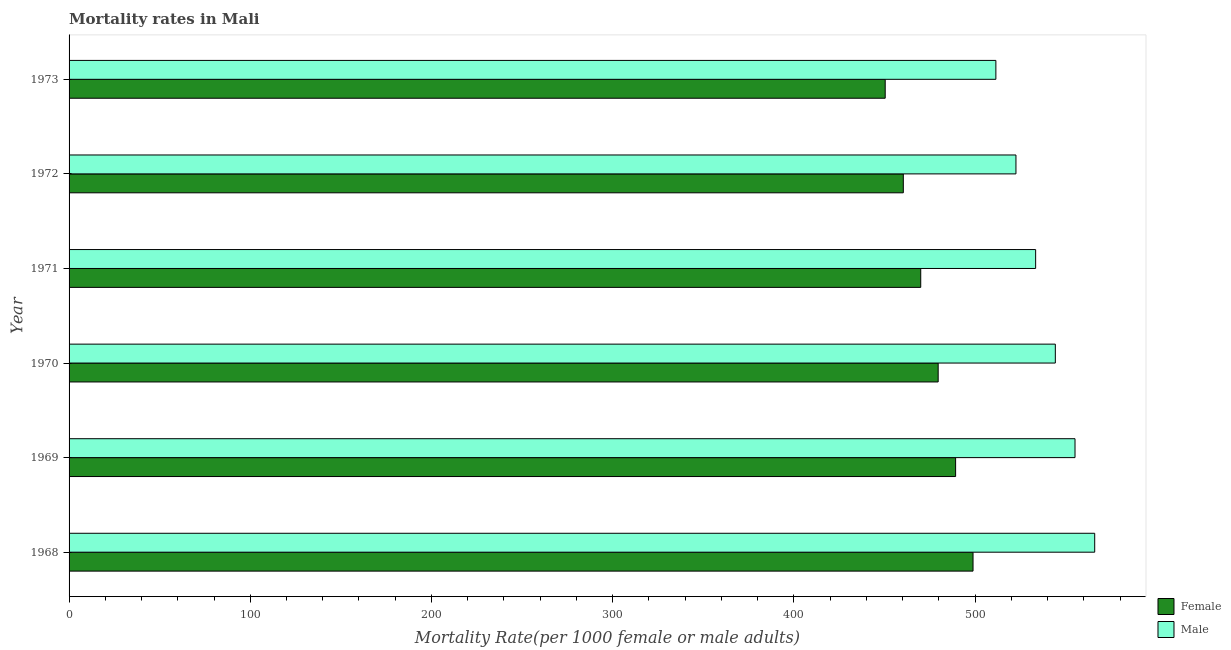How many bars are there on the 5th tick from the top?
Offer a terse response. 2. In how many cases, is the number of bars for a given year not equal to the number of legend labels?
Your response must be concise. 0. What is the male mortality rate in 1972?
Offer a very short reply. 522.56. Across all years, what is the maximum male mortality rate?
Your answer should be very brief. 566.02. Across all years, what is the minimum male mortality rate?
Offer a terse response. 511.48. In which year was the male mortality rate maximum?
Keep it short and to the point. 1968. In which year was the female mortality rate minimum?
Your answer should be very brief. 1973. What is the total female mortality rate in the graph?
Provide a short and direct response. 2848.58. What is the difference between the female mortality rate in 1969 and that in 1973?
Give a very brief answer. 38.85. What is the difference between the female mortality rate in 1968 and the male mortality rate in 1969?
Your response must be concise. -56.28. What is the average male mortality rate per year?
Your response must be concise. 538.82. In the year 1973, what is the difference between the female mortality rate and male mortality rate?
Provide a succinct answer. -61.07. What is the ratio of the female mortality rate in 1969 to that in 1973?
Provide a succinct answer. 1.09. Is the female mortality rate in 1968 less than that in 1973?
Make the answer very short. No. Is the difference between the male mortality rate in 1970 and 1973 greater than the difference between the female mortality rate in 1970 and 1973?
Your answer should be compact. Yes. What is the difference between the highest and the second highest female mortality rate?
Give a very brief answer. 9.62. What is the difference between the highest and the lowest male mortality rate?
Give a very brief answer. 54.54. In how many years, is the male mortality rate greater than the average male mortality rate taken over all years?
Ensure brevity in your answer.  3. What does the 2nd bar from the top in 1971 represents?
Your answer should be compact. Female. How many bars are there?
Your answer should be very brief. 12. How many years are there in the graph?
Provide a succinct answer. 6. What is the difference between two consecutive major ticks on the X-axis?
Keep it short and to the point. 100. Are the values on the major ticks of X-axis written in scientific E-notation?
Your answer should be very brief. No. How are the legend labels stacked?
Offer a terse response. Vertical. What is the title of the graph?
Provide a short and direct response. Mortality rates in Mali. What is the label or title of the X-axis?
Provide a succinct answer. Mortality Rate(per 1000 female or male adults). What is the Mortality Rate(per 1000 female or male adults) in Female in 1968?
Give a very brief answer. 498.88. What is the Mortality Rate(per 1000 female or male adults) of Male in 1968?
Ensure brevity in your answer.  566.02. What is the Mortality Rate(per 1000 female or male adults) of Female in 1969?
Give a very brief answer. 489.26. What is the Mortality Rate(per 1000 female or male adults) of Male in 1969?
Offer a terse response. 555.15. What is the Mortality Rate(per 1000 female or male adults) of Female in 1970?
Keep it short and to the point. 479.64. What is the Mortality Rate(per 1000 female or male adults) in Male in 1970?
Give a very brief answer. 544.29. What is the Mortality Rate(per 1000 female or male adults) in Female in 1971?
Your answer should be compact. 470.01. What is the Mortality Rate(per 1000 female or male adults) in Male in 1971?
Offer a very short reply. 533.42. What is the Mortality Rate(per 1000 female or male adults) in Female in 1972?
Your answer should be compact. 460.39. What is the Mortality Rate(per 1000 female or male adults) of Male in 1972?
Your response must be concise. 522.56. What is the Mortality Rate(per 1000 female or male adults) in Female in 1973?
Your answer should be very brief. 450.4. What is the Mortality Rate(per 1000 female or male adults) of Male in 1973?
Keep it short and to the point. 511.48. Across all years, what is the maximum Mortality Rate(per 1000 female or male adults) in Female?
Offer a terse response. 498.88. Across all years, what is the maximum Mortality Rate(per 1000 female or male adults) of Male?
Make the answer very short. 566.02. Across all years, what is the minimum Mortality Rate(per 1000 female or male adults) in Female?
Give a very brief answer. 450.4. Across all years, what is the minimum Mortality Rate(per 1000 female or male adults) in Male?
Offer a very short reply. 511.48. What is the total Mortality Rate(per 1000 female or male adults) of Female in the graph?
Keep it short and to the point. 2848.58. What is the total Mortality Rate(per 1000 female or male adults) in Male in the graph?
Offer a terse response. 3232.92. What is the difference between the Mortality Rate(per 1000 female or male adults) of Female in 1968 and that in 1969?
Your answer should be compact. 9.62. What is the difference between the Mortality Rate(per 1000 female or male adults) in Male in 1968 and that in 1969?
Your answer should be compact. 10.86. What is the difference between the Mortality Rate(per 1000 female or male adults) in Female in 1968 and that in 1970?
Make the answer very short. 19.24. What is the difference between the Mortality Rate(per 1000 female or male adults) in Male in 1968 and that in 1970?
Keep it short and to the point. 21.73. What is the difference between the Mortality Rate(per 1000 female or male adults) in Female in 1968 and that in 1971?
Your answer should be very brief. 28.86. What is the difference between the Mortality Rate(per 1000 female or male adults) in Male in 1968 and that in 1971?
Your answer should be compact. 32.59. What is the difference between the Mortality Rate(per 1000 female or male adults) of Female in 1968 and that in 1972?
Make the answer very short. 38.48. What is the difference between the Mortality Rate(per 1000 female or male adults) in Male in 1968 and that in 1972?
Offer a terse response. 43.46. What is the difference between the Mortality Rate(per 1000 female or male adults) of Female in 1968 and that in 1973?
Provide a succinct answer. 48.47. What is the difference between the Mortality Rate(per 1000 female or male adults) in Male in 1968 and that in 1973?
Offer a terse response. 54.54. What is the difference between the Mortality Rate(per 1000 female or male adults) in Female in 1969 and that in 1970?
Your answer should be very brief. 9.62. What is the difference between the Mortality Rate(per 1000 female or male adults) in Male in 1969 and that in 1970?
Ensure brevity in your answer.  10.86. What is the difference between the Mortality Rate(per 1000 female or male adults) in Female in 1969 and that in 1971?
Give a very brief answer. 19.24. What is the difference between the Mortality Rate(per 1000 female or male adults) in Male in 1969 and that in 1971?
Your answer should be very brief. 21.73. What is the difference between the Mortality Rate(per 1000 female or male adults) in Female in 1969 and that in 1972?
Your answer should be compact. 28.86. What is the difference between the Mortality Rate(per 1000 female or male adults) in Male in 1969 and that in 1972?
Ensure brevity in your answer.  32.59. What is the difference between the Mortality Rate(per 1000 female or male adults) in Female in 1969 and that in 1973?
Your answer should be compact. 38.85. What is the difference between the Mortality Rate(per 1000 female or male adults) of Male in 1969 and that in 1973?
Ensure brevity in your answer.  43.68. What is the difference between the Mortality Rate(per 1000 female or male adults) in Female in 1970 and that in 1971?
Your answer should be very brief. 9.62. What is the difference between the Mortality Rate(per 1000 female or male adults) in Male in 1970 and that in 1971?
Provide a succinct answer. 10.86. What is the difference between the Mortality Rate(per 1000 female or male adults) in Female in 1970 and that in 1972?
Make the answer very short. 19.24. What is the difference between the Mortality Rate(per 1000 female or male adults) of Male in 1970 and that in 1972?
Provide a short and direct response. 21.73. What is the difference between the Mortality Rate(per 1000 female or male adults) in Female in 1970 and that in 1973?
Provide a short and direct response. 29.23. What is the difference between the Mortality Rate(per 1000 female or male adults) of Male in 1970 and that in 1973?
Make the answer very short. 32.81. What is the difference between the Mortality Rate(per 1000 female or male adults) of Female in 1971 and that in 1972?
Your answer should be very brief. 9.62. What is the difference between the Mortality Rate(per 1000 female or male adults) in Male in 1971 and that in 1972?
Ensure brevity in your answer.  10.86. What is the difference between the Mortality Rate(per 1000 female or male adults) of Female in 1971 and that in 1973?
Keep it short and to the point. 19.61. What is the difference between the Mortality Rate(per 1000 female or male adults) in Male in 1971 and that in 1973?
Give a very brief answer. 21.95. What is the difference between the Mortality Rate(per 1000 female or male adults) in Female in 1972 and that in 1973?
Keep it short and to the point. 9.99. What is the difference between the Mortality Rate(per 1000 female or male adults) of Male in 1972 and that in 1973?
Keep it short and to the point. 11.08. What is the difference between the Mortality Rate(per 1000 female or male adults) of Female in 1968 and the Mortality Rate(per 1000 female or male adults) of Male in 1969?
Keep it short and to the point. -56.28. What is the difference between the Mortality Rate(per 1000 female or male adults) of Female in 1968 and the Mortality Rate(per 1000 female or male adults) of Male in 1970?
Offer a terse response. -45.41. What is the difference between the Mortality Rate(per 1000 female or male adults) of Female in 1968 and the Mortality Rate(per 1000 female or male adults) of Male in 1971?
Your response must be concise. -34.55. What is the difference between the Mortality Rate(per 1000 female or male adults) in Female in 1968 and the Mortality Rate(per 1000 female or male adults) in Male in 1972?
Your response must be concise. -23.68. What is the difference between the Mortality Rate(per 1000 female or male adults) in Female in 1969 and the Mortality Rate(per 1000 female or male adults) in Male in 1970?
Provide a short and direct response. -55.03. What is the difference between the Mortality Rate(per 1000 female or male adults) in Female in 1969 and the Mortality Rate(per 1000 female or male adults) in Male in 1971?
Provide a short and direct response. -44.17. What is the difference between the Mortality Rate(per 1000 female or male adults) of Female in 1969 and the Mortality Rate(per 1000 female or male adults) of Male in 1972?
Give a very brief answer. -33.3. What is the difference between the Mortality Rate(per 1000 female or male adults) in Female in 1969 and the Mortality Rate(per 1000 female or male adults) in Male in 1973?
Your answer should be very brief. -22.22. What is the difference between the Mortality Rate(per 1000 female or male adults) of Female in 1970 and the Mortality Rate(per 1000 female or male adults) of Male in 1971?
Your response must be concise. -53.79. What is the difference between the Mortality Rate(per 1000 female or male adults) of Female in 1970 and the Mortality Rate(per 1000 female or male adults) of Male in 1972?
Your answer should be compact. -42.92. What is the difference between the Mortality Rate(per 1000 female or male adults) in Female in 1970 and the Mortality Rate(per 1000 female or male adults) in Male in 1973?
Your answer should be very brief. -31.84. What is the difference between the Mortality Rate(per 1000 female or male adults) of Female in 1971 and the Mortality Rate(per 1000 female or male adults) of Male in 1972?
Your answer should be compact. -52.55. What is the difference between the Mortality Rate(per 1000 female or male adults) in Female in 1971 and the Mortality Rate(per 1000 female or male adults) in Male in 1973?
Offer a terse response. -41.46. What is the difference between the Mortality Rate(per 1000 female or male adults) in Female in 1972 and the Mortality Rate(per 1000 female or male adults) in Male in 1973?
Make the answer very short. -51.08. What is the average Mortality Rate(per 1000 female or male adults) of Female per year?
Ensure brevity in your answer.  474.76. What is the average Mortality Rate(per 1000 female or male adults) of Male per year?
Offer a terse response. 538.82. In the year 1968, what is the difference between the Mortality Rate(per 1000 female or male adults) in Female and Mortality Rate(per 1000 female or male adults) in Male?
Provide a succinct answer. -67.14. In the year 1969, what is the difference between the Mortality Rate(per 1000 female or male adults) of Female and Mortality Rate(per 1000 female or male adults) of Male?
Make the answer very short. -65.9. In the year 1970, what is the difference between the Mortality Rate(per 1000 female or male adults) of Female and Mortality Rate(per 1000 female or male adults) of Male?
Your answer should be very brief. -64.65. In the year 1971, what is the difference between the Mortality Rate(per 1000 female or male adults) in Female and Mortality Rate(per 1000 female or male adults) in Male?
Provide a short and direct response. -63.41. In the year 1972, what is the difference between the Mortality Rate(per 1000 female or male adults) in Female and Mortality Rate(per 1000 female or male adults) in Male?
Provide a succinct answer. -62.17. In the year 1973, what is the difference between the Mortality Rate(per 1000 female or male adults) of Female and Mortality Rate(per 1000 female or male adults) of Male?
Offer a terse response. -61.07. What is the ratio of the Mortality Rate(per 1000 female or male adults) of Female in 1968 to that in 1969?
Make the answer very short. 1.02. What is the ratio of the Mortality Rate(per 1000 female or male adults) in Male in 1968 to that in 1969?
Offer a terse response. 1.02. What is the ratio of the Mortality Rate(per 1000 female or male adults) in Female in 1968 to that in 1970?
Give a very brief answer. 1.04. What is the ratio of the Mortality Rate(per 1000 female or male adults) in Male in 1968 to that in 1970?
Offer a very short reply. 1.04. What is the ratio of the Mortality Rate(per 1000 female or male adults) of Female in 1968 to that in 1971?
Give a very brief answer. 1.06. What is the ratio of the Mortality Rate(per 1000 female or male adults) in Male in 1968 to that in 1971?
Provide a succinct answer. 1.06. What is the ratio of the Mortality Rate(per 1000 female or male adults) in Female in 1968 to that in 1972?
Offer a very short reply. 1.08. What is the ratio of the Mortality Rate(per 1000 female or male adults) of Male in 1968 to that in 1972?
Make the answer very short. 1.08. What is the ratio of the Mortality Rate(per 1000 female or male adults) in Female in 1968 to that in 1973?
Give a very brief answer. 1.11. What is the ratio of the Mortality Rate(per 1000 female or male adults) in Male in 1968 to that in 1973?
Make the answer very short. 1.11. What is the ratio of the Mortality Rate(per 1000 female or male adults) of Female in 1969 to that in 1970?
Your response must be concise. 1.02. What is the ratio of the Mortality Rate(per 1000 female or male adults) in Male in 1969 to that in 1970?
Keep it short and to the point. 1.02. What is the ratio of the Mortality Rate(per 1000 female or male adults) in Female in 1969 to that in 1971?
Make the answer very short. 1.04. What is the ratio of the Mortality Rate(per 1000 female or male adults) of Male in 1969 to that in 1971?
Offer a terse response. 1.04. What is the ratio of the Mortality Rate(per 1000 female or male adults) in Female in 1969 to that in 1972?
Make the answer very short. 1.06. What is the ratio of the Mortality Rate(per 1000 female or male adults) of Male in 1969 to that in 1972?
Make the answer very short. 1.06. What is the ratio of the Mortality Rate(per 1000 female or male adults) of Female in 1969 to that in 1973?
Give a very brief answer. 1.09. What is the ratio of the Mortality Rate(per 1000 female or male adults) of Male in 1969 to that in 1973?
Your answer should be very brief. 1.09. What is the ratio of the Mortality Rate(per 1000 female or male adults) in Female in 1970 to that in 1971?
Make the answer very short. 1.02. What is the ratio of the Mortality Rate(per 1000 female or male adults) of Male in 1970 to that in 1971?
Offer a terse response. 1.02. What is the ratio of the Mortality Rate(per 1000 female or male adults) in Female in 1970 to that in 1972?
Ensure brevity in your answer.  1.04. What is the ratio of the Mortality Rate(per 1000 female or male adults) of Male in 1970 to that in 1972?
Provide a short and direct response. 1.04. What is the ratio of the Mortality Rate(per 1000 female or male adults) of Female in 1970 to that in 1973?
Keep it short and to the point. 1.06. What is the ratio of the Mortality Rate(per 1000 female or male adults) of Male in 1970 to that in 1973?
Offer a very short reply. 1.06. What is the ratio of the Mortality Rate(per 1000 female or male adults) of Female in 1971 to that in 1972?
Keep it short and to the point. 1.02. What is the ratio of the Mortality Rate(per 1000 female or male adults) of Male in 1971 to that in 1972?
Make the answer very short. 1.02. What is the ratio of the Mortality Rate(per 1000 female or male adults) in Female in 1971 to that in 1973?
Offer a very short reply. 1.04. What is the ratio of the Mortality Rate(per 1000 female or male adults) of Male in 1971 to that in 1973?
Your answer should be compact. 1.04. What is the ratio of the Mortality Rate(per 1000 female or male adults) in Female in 1972 to that in 1973?
Offer a very short reply. 1.02. What is the ratio of the Mortality Rate(per 1000 female or male adults) of Male in 1972 to that in 1973?
Offer a terse response. 1.02. What is the difference between the highest and the second highest Mortality Rate(per 1000 female or male adults) of Female?
Give a very brief answer. 9.62. What is the difference between the highest and the second highest Mortality Rate(per 1000 female or male adults) of Male?
Ensure brevity in your answer.  10.86. What is the difference between the highest and the lowest Mortality Rate(per 1000 female or male adults) in Female?
Provide a short and direct response. 48.47. What is the difference between the highest and the lowest Mortality Rate(per 1000 female or male adults) in Male?
Offer a terse response. 54.54. 